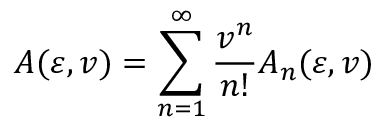Convert formula to latex. <formula><loc_0><loc_0><loc_500><loc_500>A ( \varepsilon , v ) = \sum _ { n = 1 } ^ { \infty } { \frac { v ^ { n } } { n ! } } A _ { n } ( \varepsilon , v )</formula> 